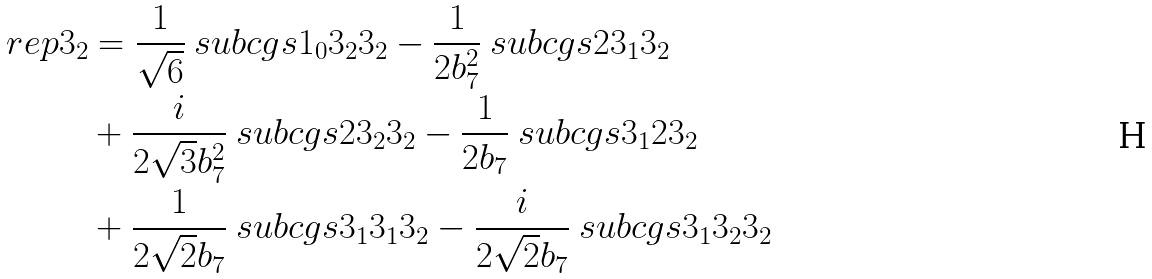<formula> <loc_0><loc_0><loc_500><loc_500>\ r e p { 3 } _ { 2 } & = \frac { 1 } { \sqrt { 6 } } \ s u b c g s { 1 _ { 0 } } { 3 _ { 2 } } { 3 _ { 2 } } - \frac { 1 } { 2 b _ { 7 } ^ { 2 } } \ s u b c g s { 2 } { 3 _ { 1 } } { 3 _ { 2 } } \\ & + \frac { i } { 2 \sqrt { 3 } b _ { 7 } ^ { 2 } } \ s u b c g s { 2 } { 3 _ { 2 } } { 3 _ { 2 } } - \frac { 1 } { 2 b _ { 7 } } \ s u b c g s { 3 _ { 1 } } { 2 } { 3 _ { 2 } } \\ & + \frac { 1 } { 2 \sqrt { 2 } b _ { 7 } } \ s u b c g s { 3 _ { 1 } } { 3 _ { 1 } } { 3 _ { 2 } } - \frac { i } { 2 \sqrt { 2 } b _ { 7 } } \ s u b c g s { 3 _ { 1 } } { 3 _ { 2 } } { 3 _ { 2 } }</formula> 